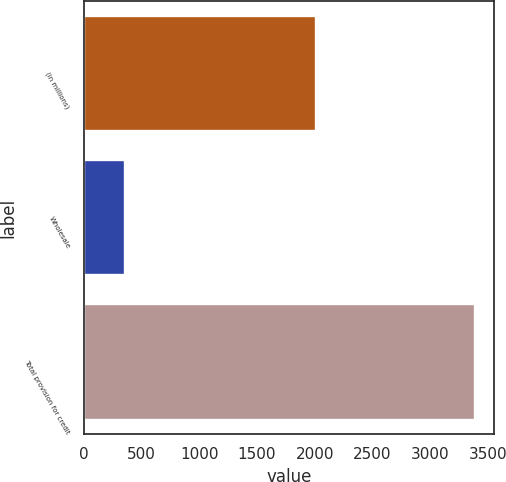Convert chart. <chart><loc_0><loc_0><loc_500><loc_500><bar_chart><fcel>(in millions)<fcel>Wholesale<fcel>Total provision for credit<nl><fcel>2012<fcel>359<fcel>3387<nl></chart> 